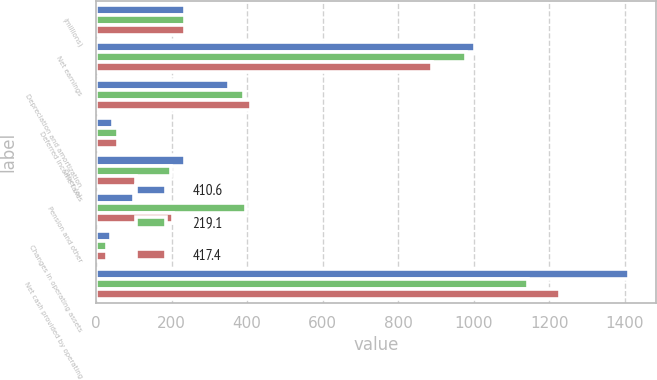Convert chart to OTSL. <chart><loc_0><loc_0><loc_500><loc_500><stacked_bar_chart><ecel><fcel>(millions)<fcel>Net earnings<fcel>Depreciation and amortization<fcel>Deferred income taxes<fcel>Other (a)<fcel>Pension and other<fcel>Changes in operating assets<fcel>Net cash provided by operating<nl><fcel>410.6<fcel>235.2<fcel>1004.1<fcel>352.7<fcel>43.7<fcel>235.2<fcel>99.3<fcel>38.5<fcel>1410.5<nl><fcel>219.1<fcel>235.2<fcel>980.4<fcel>391.8<fcel>59.2<fcel>199.3<fcel>397.3<fcel>28.3<fcel>1143.3<nl><fcel>417.4<fcel>235.2<fcel>890.6<fcel>410<fcel>57.7<fcel>104.5<fcel>204<fcel>29.8<fcel>1229<nl></chart> 